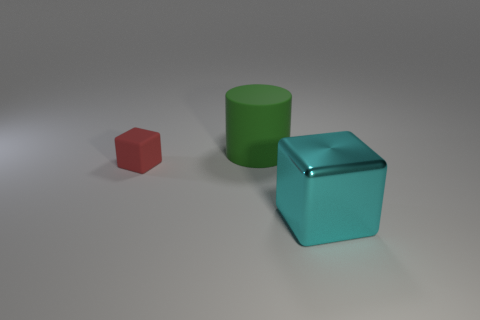Add 2 gray matte cylinders. How many objects exist? 5 Subtract all cylinders. How many objects are left? 2 Subtract all large cyan shiny objects. Subtract all big cyan cubes. How many objects are left? 1 Add 1 green objects. How many green objects are left? 2 Add 2 large blue objects. How many large blue objects exist? 2 Subtract 0 gray cubes. How many objects are left? 3 